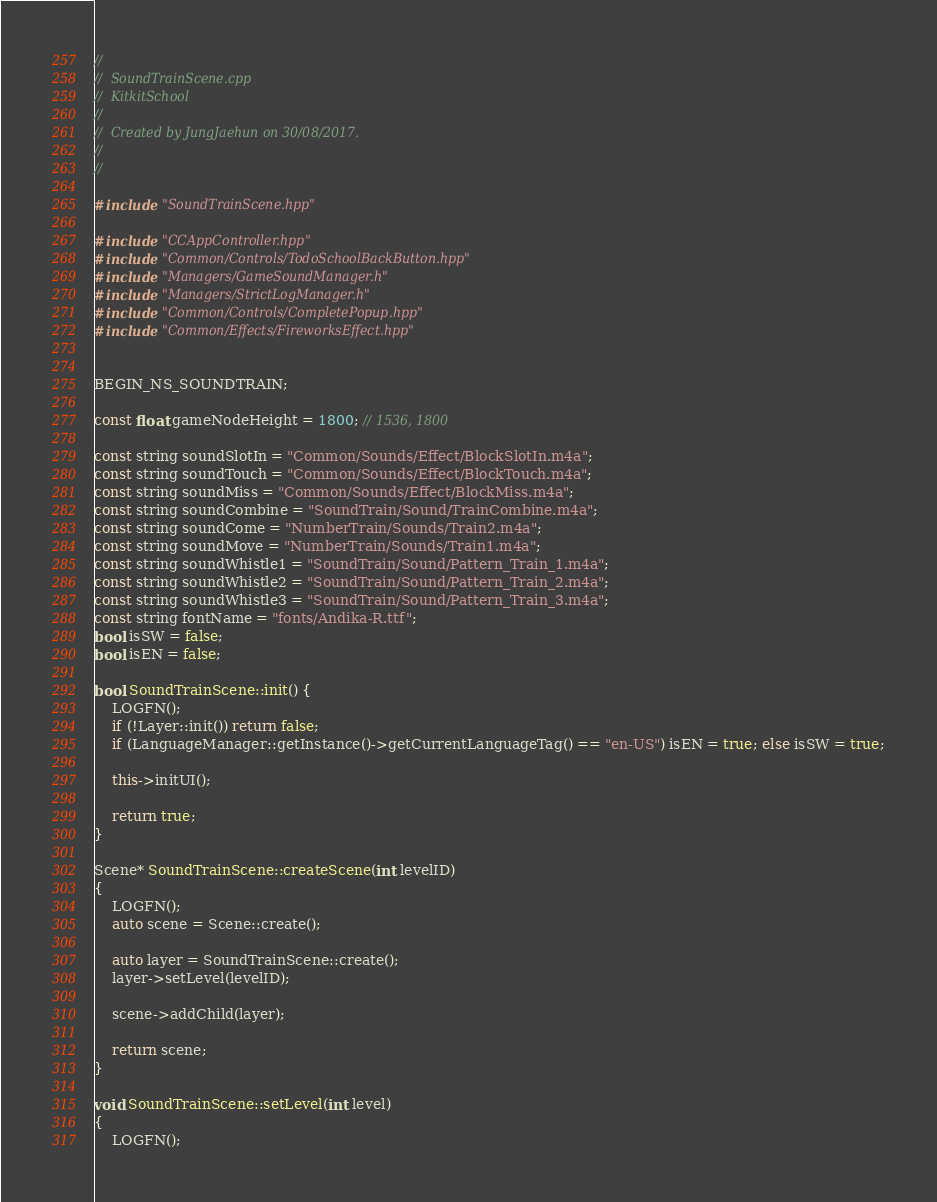<code> <loc_0><loc_0><loc_500><loc_500><_C++_>//
//  SoundTrainScene.cpp
//  KitkitSchool
//
//  Created by JungJaehun on 30/08/2017.
//
//

#include "SoundTrainScene.hpp"

#include "CCAppController.hpp"
#include "Common/Controls/TodoSchoolBackButton.hpp"
#include "Managers/GameSoundManager.h"
#include "Managers/StrictLogManager.h"
#include "Common/Controls/CompletePopup.hpp"
#include "Common/Effects/FireworksEffect.hpp"


BEGIN_NS_SOUNDTRAIN;

const float gameNodeHeight = 1800; // 1536, 1800

const string soundSlotIn = "Common/Sounds/Effect/BlockSlotIn.m4a";
const string soundTouch = "Common/Sounds/Effect/BlockTouch.m4a";
const string soundMiss = "Common/Sounds/Effect/BlockMiss.m4a";
const string soundCombine = "SoundTrain/Sound/TrainCombine.m4a";
const string soundCome = "NumberTrain/Sounds/Train2.m4a";
const string soundMove = "NumberTrain/Sounds/Train1.m4a";
const string soundWhistle1 = "SoundTrain/Sound/Pattern_Train_1.m4a";
const string soundWhistle2 = "SoundTrain/Sound/Pattern_Train_2.m4a";
const string soundWhistle3 = "SoundTrain/Sound/Pattern_Train_3.m4a";
const string fontName = "fonts/Andika-R.ttf";
bool isSW = false;
bool isEN = false;

bool SoundTrainScene::init() {
    LOGFN();
    if (!Layer::init()) return false;
    if (LanguageManager::getInstance()->getCurrentLanguageTag() == "en-US") isEN = true; else isSW = true;
    
    this->initUI();
    
    return true;
}

Scene* SoundTrainScene::createScene(int levelID)
{
    LOGFN();
    auto scene = Scene::create();
    
    auto layer = SoundTrainScene::create();
    layer->setLevel(levelID);

    scene->addChild(layer);
    
    return scene;
}

void SoundTrainScene::setLevel(int level)
{
    LOGFN();</code> 